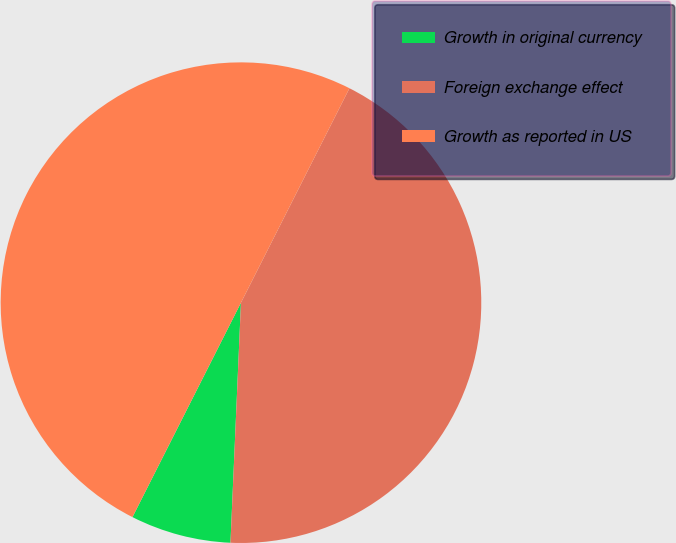Convert chart. <chart><loc_0><loc_0><loc_500><loc_500><pie_chart><fcel>Growth in original currency<fcel>Foreign exchange effect<fcel>Growth as reported in US<nl><fcel>6.76%<fcel>43.24%<fcel>50.0%<nl></chart> 